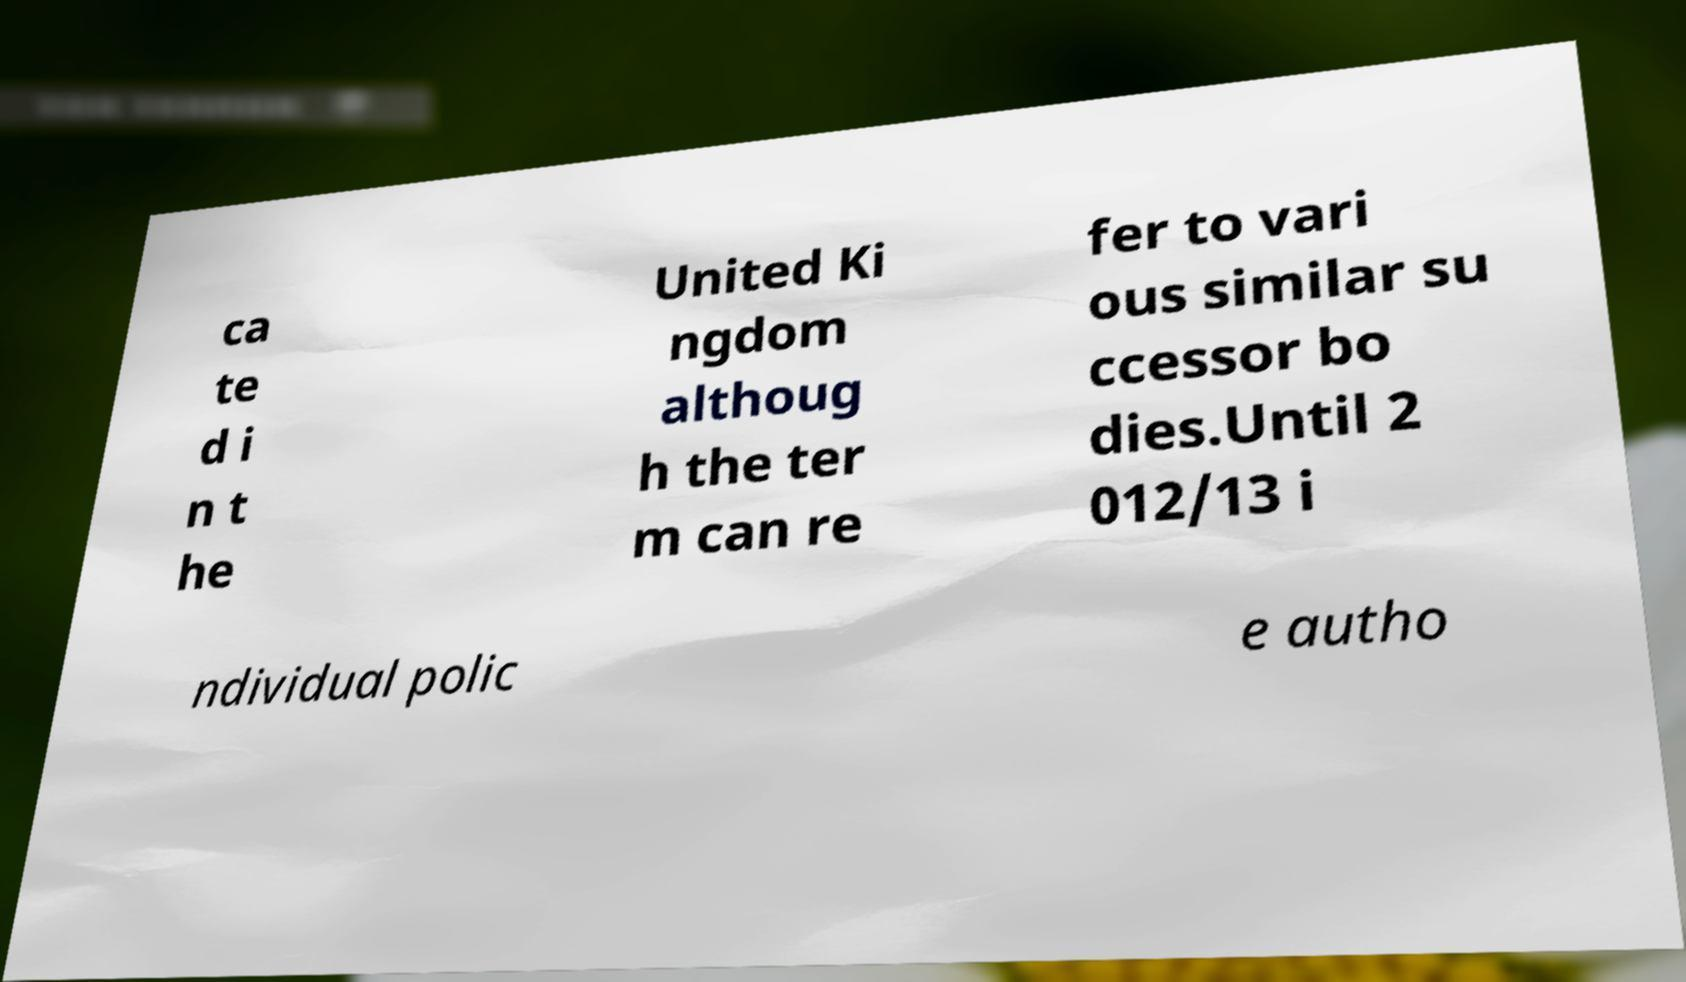Please read and relay the text visible in this image. What does it say? ca te d i n t he United Ki ngdom althoug h the ter m can re fer to vari ous similar su ccessor bo dies.Until 2 012/13 i ndividual polic e autho 